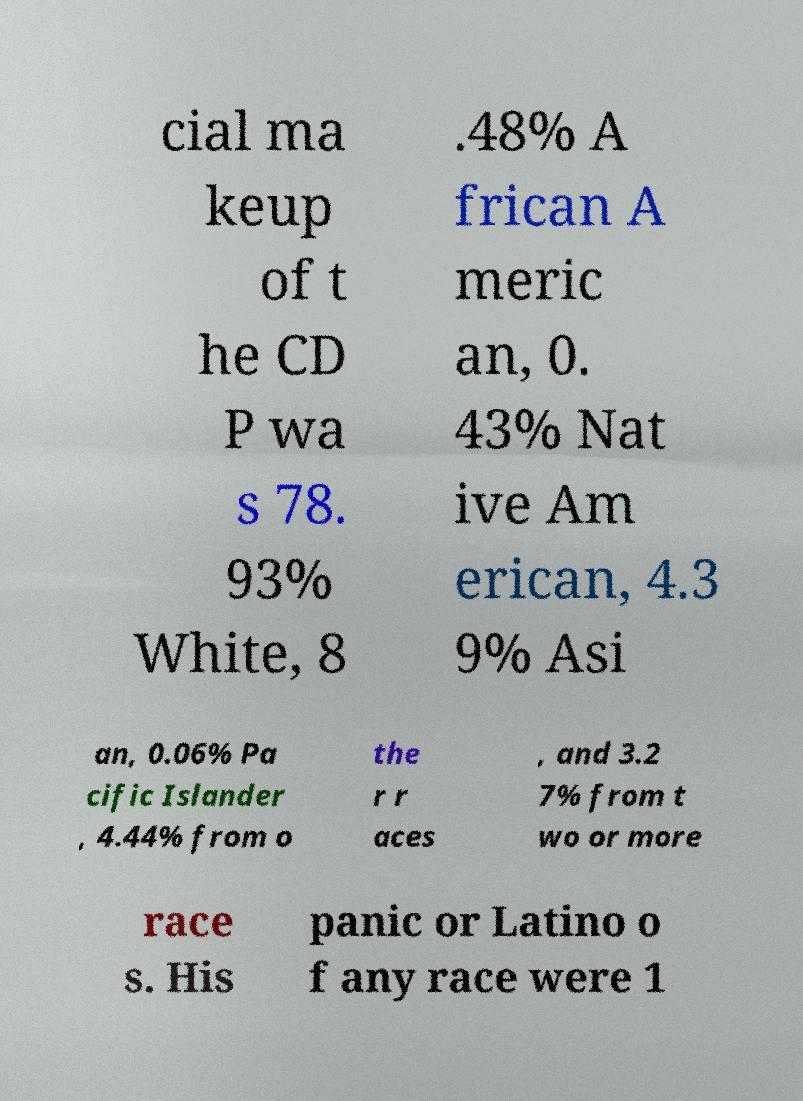What messages or text are displayed in this image? I need them in a readable, typed format. cial ma keup of t he CD P wa s 78. 93% White, 8 .48% A frican A meric an, 0. 43% Nat ive Am erican, 4.3 9% Asi an, 0.06% Pa cific Islander , 4.44% from o the r r aces , and 3.2 7% from t wo or more race s. His panic or Latino o f any race were 1 